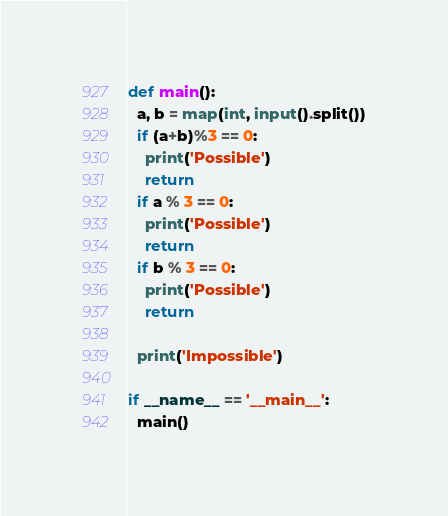<code> <loc_0><loc_0><loc_500><loc_500><_Python_>def main():
  a, b = map(int, input().split())
  if (a+b)%3 == 0:
    print('Possible')
    return
  if a % 3 == 0:
    print('Possible')
    return
  if b % 3 == 0:
    print('Possible')
    return
  
  print('Impossible')
  
if __name__ == '__main__':
  main()</code> 